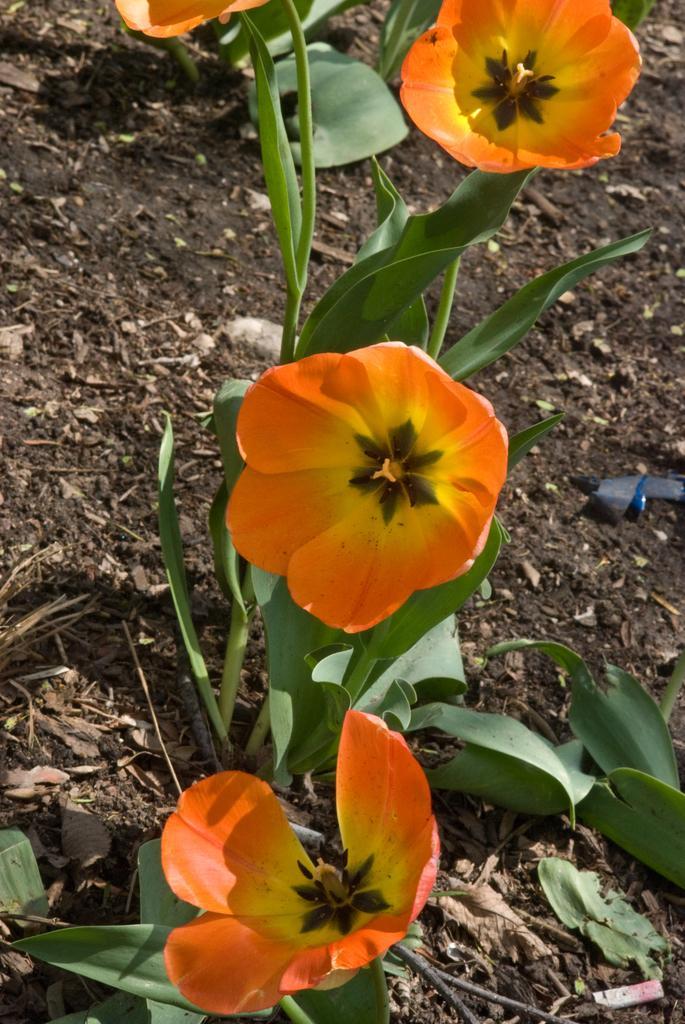Could you give a brief overview of what you see in this image? In this image I can see few flowers in yellow and orange color and I can see leaves in green color. 